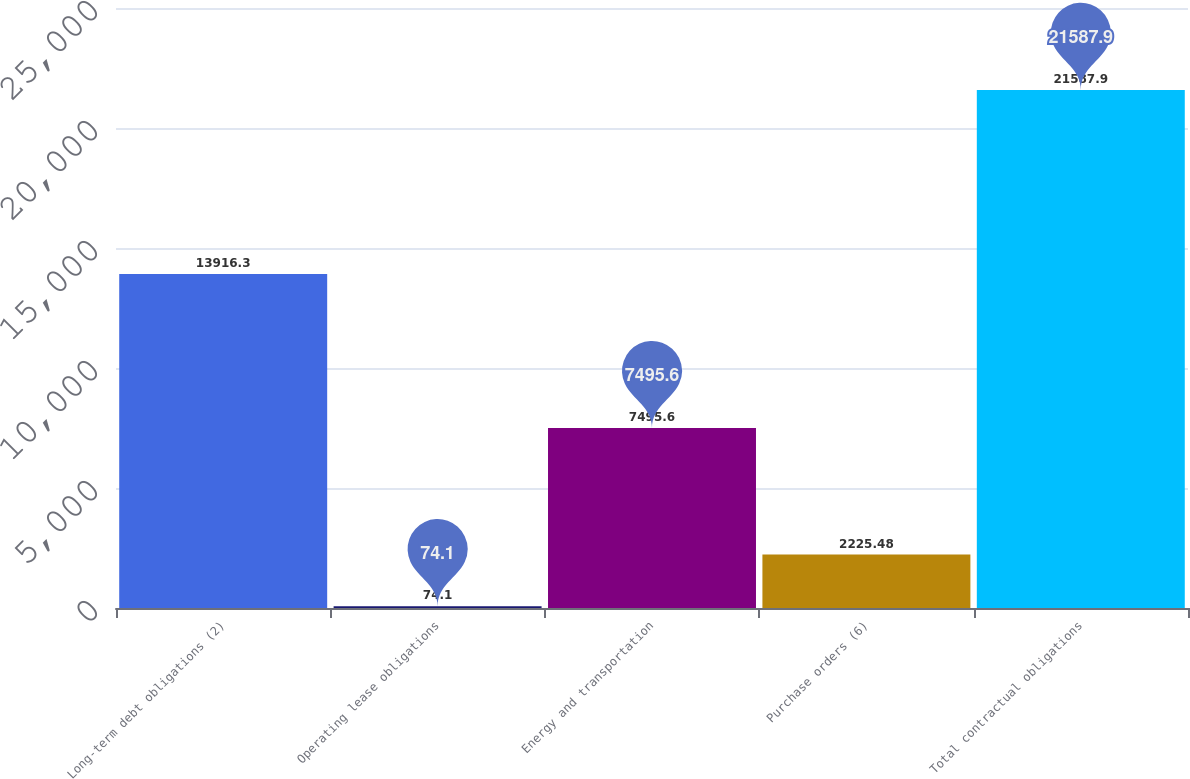Convert chart to OTSL. <chart><loc_0><loc_0><loc_500><loc_500><bar_chart><fcel>Long-term debt obligations (2)<fcel>Operating lease obligations<fcel>Energy and transportation<fcel>Purchase orders (6)<fcel>Total contractual obligations<nl><fcel>13916.3<fcel>74.1<fcel>7495.6<fcel>2225.48<fcel>21587.9<nl></chart> 